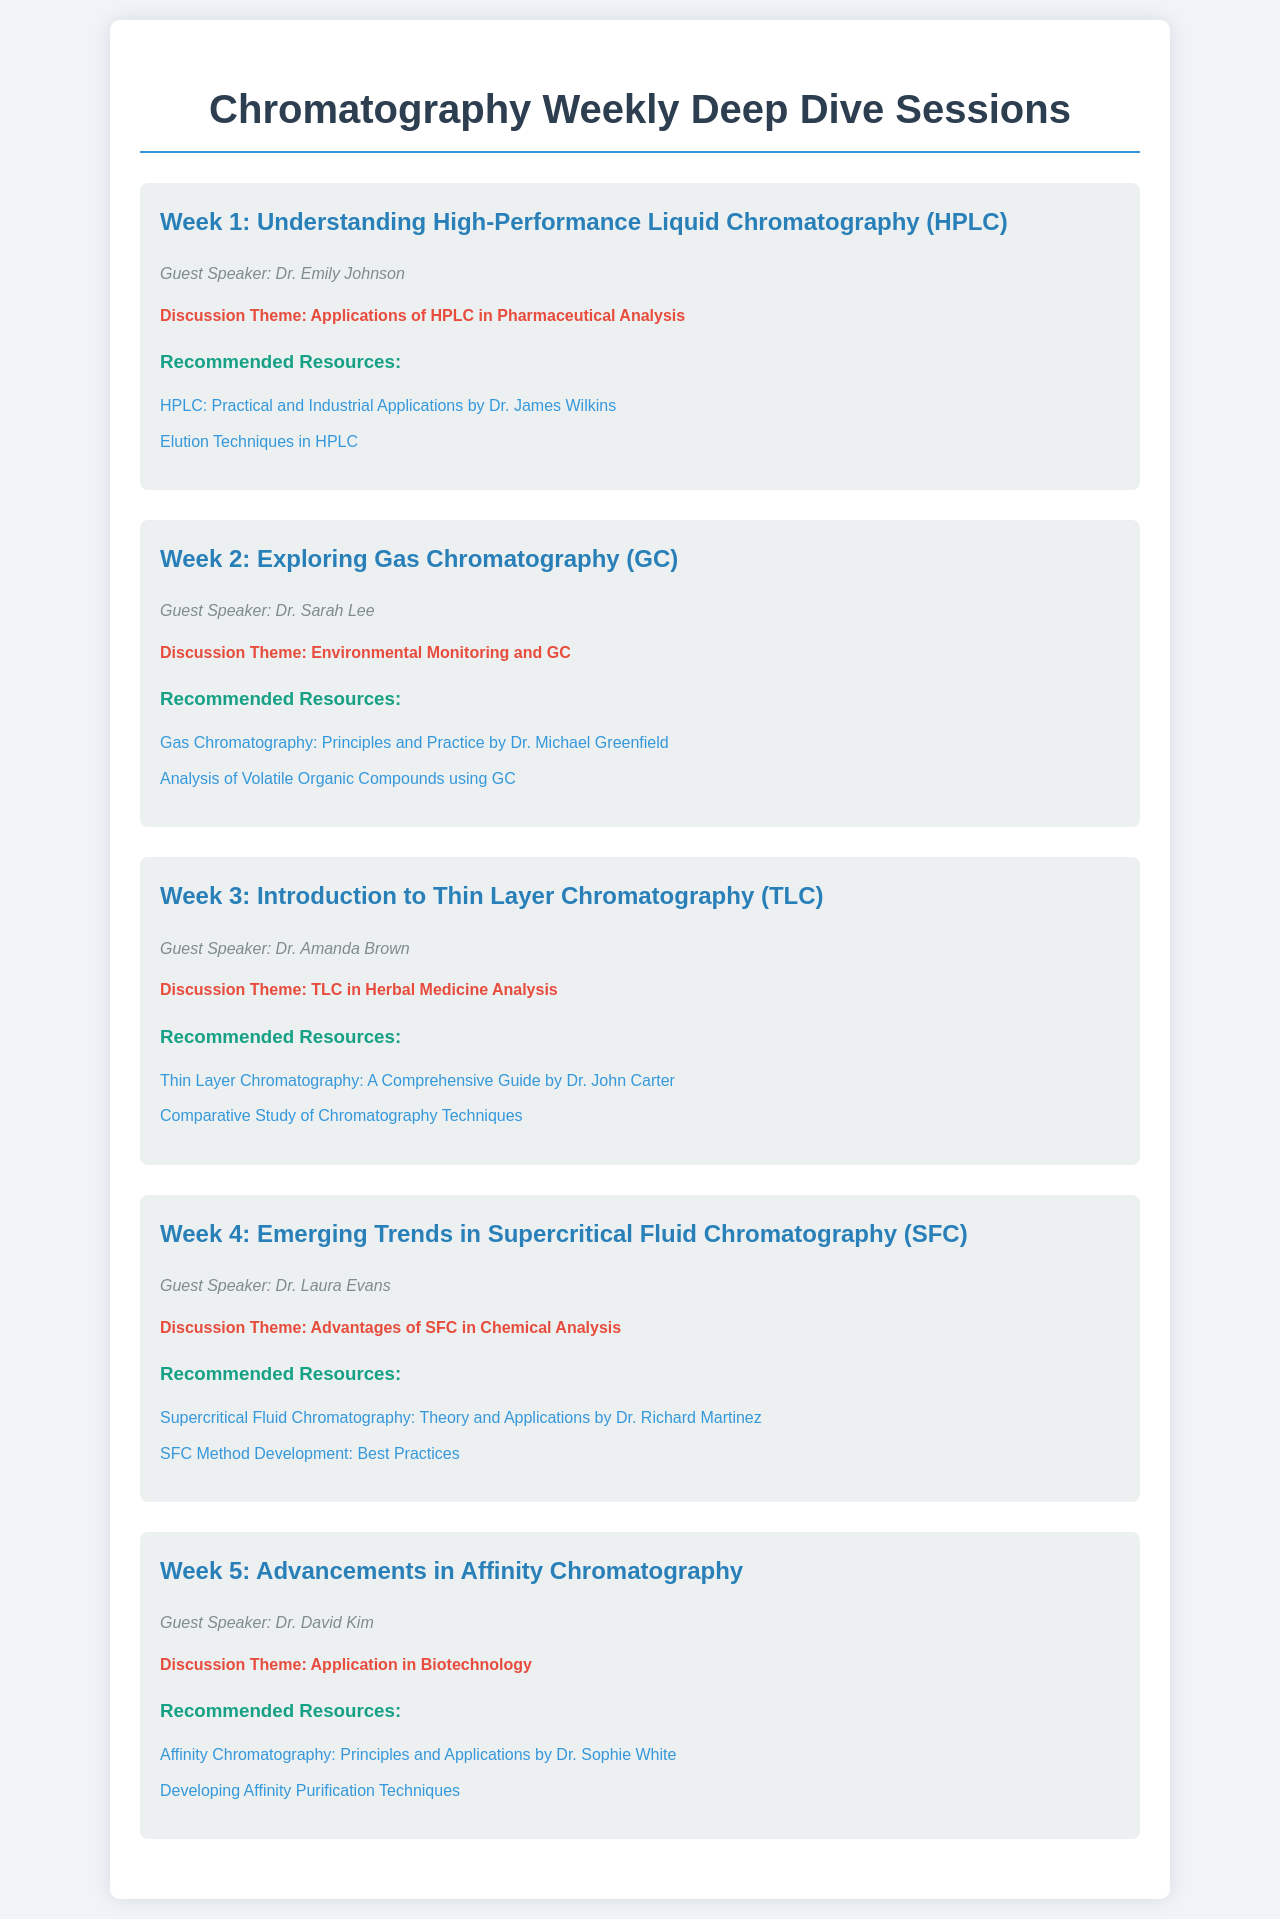What is the theme of Week 1? The theme for Week 1 is related to High-Performance Liquid Chromatography and its applications in pharmaceutical analysis.
Answer: Applications of HPLC in Pharmaceutical Analysis Who is the guest speaker for Week 3? The document lists Dr. Amanda Brown as the guest speaker for Week 3.
Answer: Dr. Amanda Brown What is the title of the resource recommended for Week 2? The document mentions specific resources, including the one that is relevant to Week 2 on Gas Chromatography.
Answer: Gas Chromatography: Principles and Practice by Dr. Michael Greenfield Which chromatography technique is introduced in Week 4? The document specifies the technique being discussed in Week 4.
Answer: Supercritical Fluid Chromatography (SFC) How many weeks are scheduled for the deep dive sessions? The document outlines a total of five weeks for the sessions.
Answer: 5 What is a recommended resource for Week 5? The document lists specific resources for Week 5, including one highlighting its principles and applications.
Answer: Affinity Chromatography: Principles and Applications by Dr. Sophie White What is the focus of the discussion theme in Week 2? The focus of the Week 2 discussion theme revolves around the application of Gas Chromatography.
Answer: Environmental Monitoring and GC Who is the guest speaker for Week 4? The document identifies Dr. Laura Evans as the guest speaker for Week 4.
Answer: Dr. Laura Evans What does the Week 3 guest speaker analyze with Thin Layer Chromatography? The discussion theme indicates the application of TLC in a specific field.
Answer: Herbal Medicine Analysis 